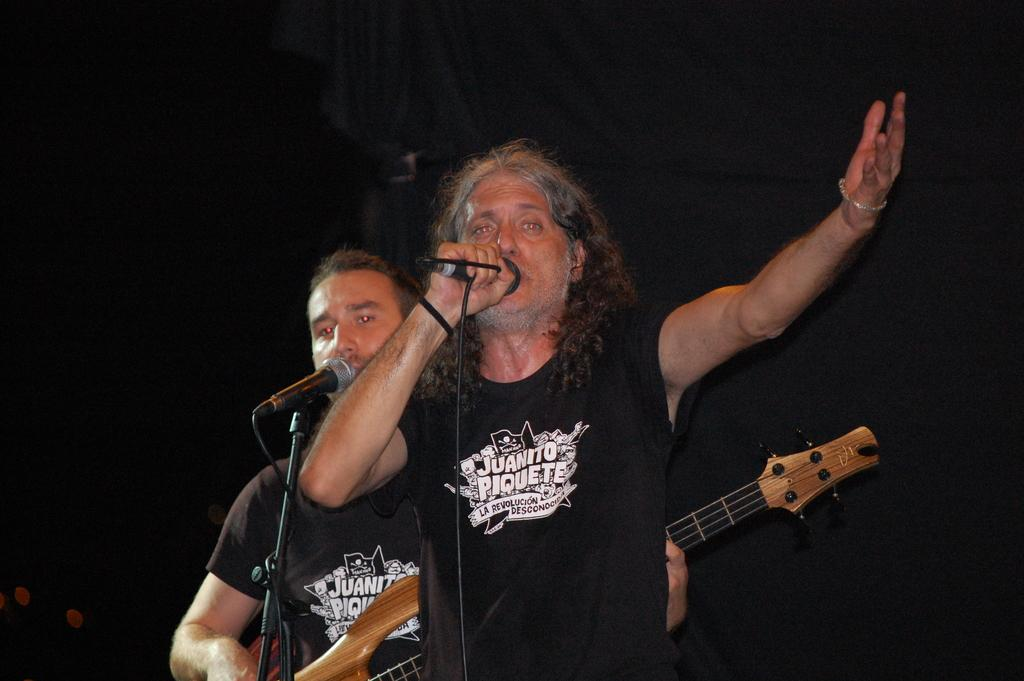How many people are in the image? There are two men in the image. What is one of the men holding? One of the men is holding a guitar. What is the man with the guitar doing? The man with the guitar is playing it. What are both men doing in the image? Both men are singing. What are they using to amplify their voices? They are using microphones. What can be observed about the background of the image? The background of the image is dark. How many clocks can be seen hanging on the wall in the image? There are no clocks visible in the image. What type of glass object is being used by the men in the image? There is no glass object present in the image; they are using microphones. 